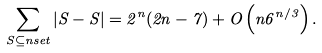<formula> <loc_0><loc_0><loc_500><loc_500>\sum _ { S \subseteq n s e t } | S - S | = 2 ^ { n } ( 2 n - 7 ) + O \left ( n 6 ^ { n / 3 } \right ) .</formula> 